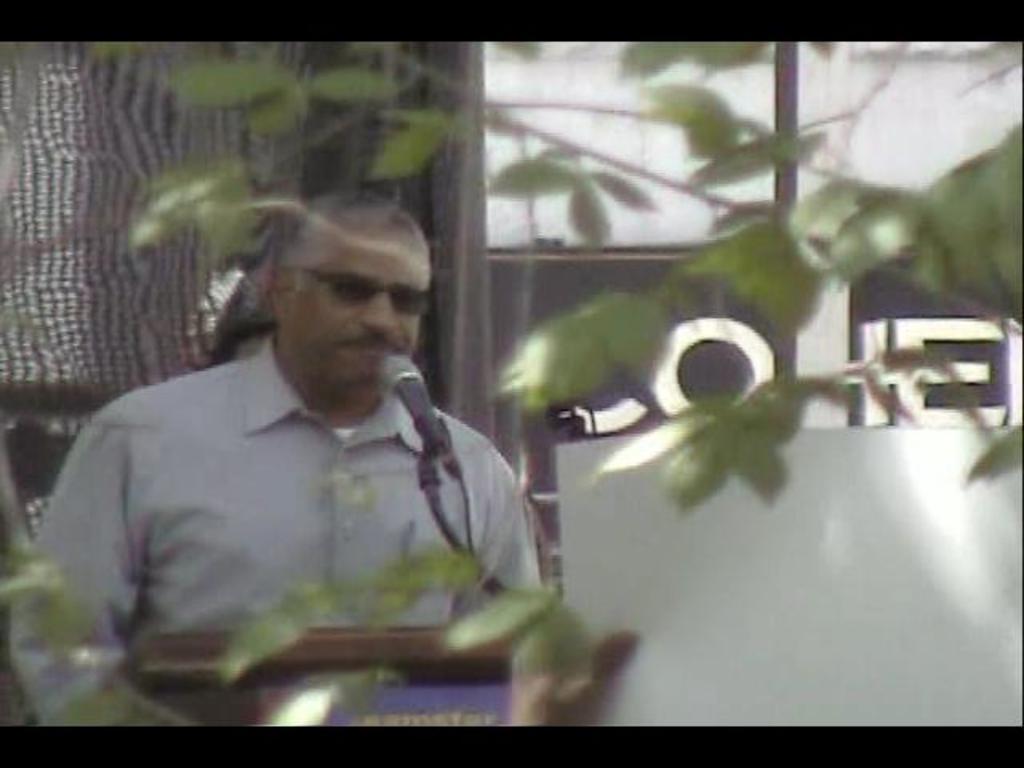In one or two sentences, can you explain what this image depicts? In this image I can see a person is wearing white shirt. I can see a mic and wire. In front I can see few green leaves. Background I can see a brown and white color object. 